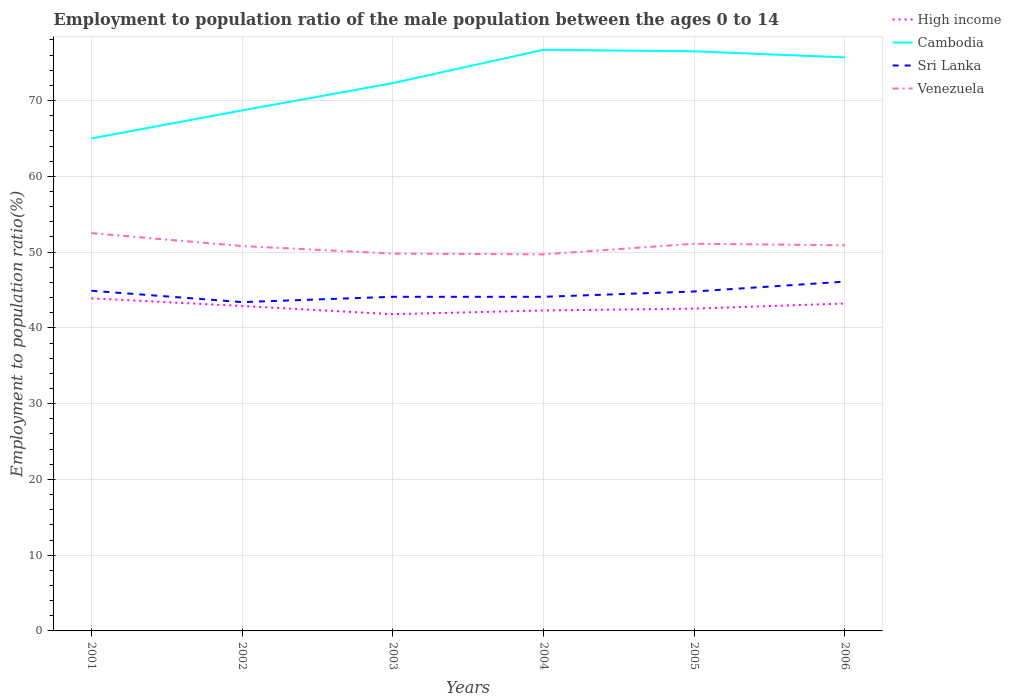How many different coloured lines are there?
Your answer should be very brief. 4. Across all years, what is the maximum employment to population ratio in High income?
Your answer should be compact. 41.8. In which year was the employment to population ratio in Sri Lanka maximum?
Offer a very short reply. 2002. What is the total employment to population ratio in High income in the graph?
Your answer should be compact. 2.09. What is the difference between the highest and the second highest employment to population ratio in High income?
Offer a very short reply. 2.09. Is the employment to population ratio in Cambodia strictly greater than the employment to population ratio in Sri Lanka over the years?
Your answer should be compact. No. How many lines are there?
Make the answer very short. 4. How many years are there in the graph?
Provide a short and direct response. 6. Are the values on the major ticks of Y-axis written in scientific E-notation?
Ensure brevity in your answer.  No. Does the graph contain any zero values?
Your response must be concise. No. Where does the legend appear in the graph?
Offer a terse response. Top right. How are the legend labels stacked?
Your answer should be very brief. Vertical. What is the title of the graph?
Offer a terse response. Employment to population ratio of the male population between the ages 0 to 14. What is the label or title of the Y-axis?
Your answer should be compact. Employment to population ratio(%). What is the Employment to population ratio(%) in High income in 2001?
Your answer should be compact. 43.89. What is the Employment to population ratio(%) in Cambodia in 2001?
Give a very brief answer. 65. What is the Employment to population ratio(%) in Sri Lanka in 2001?
Offer a terse response. 44.9. What is the Employment to population ratio(%) of Venezuela in 2001?
Provide a short and direct response. 52.5. What is the Employment to population ratio(%) in High income in 2002?
Provide a short and direct response. 42.88. What is the Employment to population ratio(%) in Cambodia in 2002?
Your answer should be compact. 68.7. What is the Employment to population ratio(%) in Sri Lanka in 2002?
Your answer should be compact. 43.4. What is the Employment to population ratio(%) in Venezuela in 2002?
Ensure brevity in your answer.  50.8. What is the Employment to population ratio(%) of High income in 2003?
Ensure brevity in your answer.  41.8. What is the Employment to population ratio(%) in Cambodia in 2003?
Give a very brief answer. 72.3. What is the Employment to population ratio(%) in Sri Lanka in 2003?
Provide a succinct answer. 44.1. What is the Employment to population ratio(%) of Venezuela in 2003?
Your answer should be very brief. 49.8. What is the Employment to population ratio(%) in High income in 2004?
Provide a short and direct response. 42.3. What is the Employment to population ratio(%) of Cambodia in 2004?
Your answer should be very brief. 76.7. What is the Employment to population ratio(%) in Sri Lanka in 2004?
Offer a terse response. 44.1. What is the Employment to population ratio(%) of Venezuela in 2004?
Ensure brevity in your answer.  49.7. What is the Employment to population ratio(%) of High income in 2005?
Offer a very short reply. 42.54. What is the Employment to population ratio(%) of Cambodia in 2005?
Make the answer very short. 76.5. What is the Employment to population ratio(%) in Sri Lanka in 2005?
Your answer should be compact. 44.8. What is the Employment to population ratio(%) of Venezuela in 2005?
Offer a terse response. 51.1. What is the Employment to population ratio(%) in High income in 2006?
Give a very brief answer. 43.22. What is the Employment to population ratio(%) in Cambodia in 2006?
Offer a very short reply. 75.7. What is the Employment to population ratio(%) in Sri Lanka in 2006?
Keep it short and to the point. 46.1. What is the Employment to population ratio(%) of Venezuela in 2006?
Your answer should be compact. 50.9. Across all years, what is the maximum Employment to population ratio(%) in High income?
Provide a short and direct response. 43.89. Across all years, what is the maximum Employment to population ratio(%) of Cambodia?
Make the answer very short. 76.7. Across all years, what is the maximum Employment to population ratio(%) of Sri Lanka?
Offer a very short reply. 46.1. Across all years, what is the maximum Employment to population ratio(%) of Venezuela?
Your response must be concise. 52.5. Across all years, what is the minimum Employment to population ratio(%) in High income?
Ensure brevity in your answer.  41.8. Across all years, what is the minimum Employment to population ratio(%) of Cambodia?
Keep it short and to the point. 65. Across all years, what is the minimum Employment to population ratio(%) of Sri Lanka?
Provide a succinct answer. 43.4. Across all years, what is the minimum Employment to population ratio(%) in Venezuela?
Your answer should be compact. 49.7. What is the total Employment to population ratio(%) in High income in the graph?
Give a very brief answer. 256.63. What is the total Employment to population ratio(%) in Cambodia in the graph?
Your response must be concise. 434.9. What is the total Employment to population ratio(%) in Sri Lanka in the graph?
Provide a succinct answer. 267.4. What is the total Employment to population ratio(%) of Venezuela in the graph?
Provide a succinct answer. 304.8. What is the difference between the Employment to population ratio(%) in High income in 2001 and that in 2002?
Provide a succinct answer. 1.01. What is the difference between the Employment to population ratio(%) in Cambodia in 2001 and that in 2002?
Give a very brief answer. -3.7. What is the difference between the Employment to population ratio(%) of Sri Lanka in 2001 and that in 2002?
Keep it short and to the point. 1.5. What is the difference between the Employment to population ratio(%) in Venezuela in 2001 and that in 2002?
Give a very brief answer. 1.7. What is the difference between the Employment to population ratio(%) in High income in 2001 and that in 2003?
Give a very brief answer. 2.09. What is the difference between the Employment to population ratio(%) of Cambodia in 2001 and that in 2003?
Make the answer very short. -7.3. What is the difference between the Employment to population ratio(%) in Venezuela in 2001 and that in 2003?
Offer a terse response. 2.7. What is the difference between the Employment to population ratio(%) in High income in 2001 and that in 2004?
Your answer should be compact. 1.6. What is the difference between the Employment to population ratio(%) in Cambodia in 2001 and that in 2004?
Offer a very short reply. -11.7. What is the difference between the Employment to population ratio(%) of High income in 2001 and that in 2005?
Offer a very short reply. 1.35. What is the difference between the Employment to population ratio(%) in Cambodia in 2001 and that in 2005?
Offer a terse response. -11.5. What is the difference between the Employment to population ratio(%) of Sri Lanka in 2001 and that in 2005?
Give a very brief answer. 0.1. What is the difference between the Employment to population ratio(%) in Venezuela in 2001 and that in 2005?
Your answer should be very brief. 1.4. What is the difference between the Employment to population ratio(%) in High income in 2001 and that in 2006?
Ensure brevity in your answer.  0.68. What is the difference between the Employment to population ratio(%) of Cambodia in 2001 and that in 2006?
Offer a very short reply. -10.7. What is the difference between the Employment to population ratio(%) in High income in 2002 and that in 2003?
Your answer should be very brief. 1.08. What is the difference between the Employment to population ratio(%) of Sri Lanka in 2002 and that in 2003?
Make the answer very short. -0.7. What is the difference between the Employment to population ratio(%) in Venezuela in 2002 and that in 2003?
Your answer should be compact. 1. What is the difference between the Employment to population ratio(%) of High income in 2002 and that in 2004?
Ensure brevity in your answer.  0.58. What is the difference between the Employment to population ratio(%) in Sri Lanka in 2002 and that in 2004?
Make the answer very short. -0.7. What is the difference between the Employment to population ratio(%) of High income in 2002 and that in 2005?
Provide a short and direct response. 0.34. What is the difference between the Employment to population ratio(%) of Cambodia in 2002 and that in 2005?
Offer a very short reply. -7.8. What is the difference between the Employment to population ratio(%) in High income in 2002 and that in 2006?
Your answer should be very brief. -0.33. What is the difference between the Employment to population ratio(%) of High income in 2003 and that in 2004?
Offer a terse response. -0.49. What is the difference between the Employment to population ratio(%) of Cambodia in 2003 and that in 2004?
Make the answer very short. -4.4. What is the difference between the Employment to population ratio(%) in Sri Lanka in 2003 and that in 2004?
Provide a succinct answer. 0. What is the difference between the Employment to population ratio(%) in High income in 2003 and that in 2005?
Give a very brief answer. -0.74. What is the difference between the Employment to population ratio(%) in Cambodia in 2003 and that in 2005?
Make the answer very short. -4.2. What is the difference between the Employment to population ratio(%) of High income in 2003 and that in 2006?
Ensure brevity in your answer.  -1.41. What is the difference between the Employment to population ratio(%) of Sri Lanka in 2003 and that in 2006?
Offer a terse response. -2. What is the difference between the Employment to population ratio(%) of Venezuela in 2003 and that in 2006?
Provide a succinct answer. -1.1. What is the difference between the Employment to population ratio(%) of High income in 2004 and that in 2005?
Provide a short and direct response. -0.24. What is the difference between the Employment to population ratio(%) of High income in 2004 and that in 2006?
Keep it short and to the point. -0.92. What is the difference between the Employment to population ratio(%) in Cambodia in 2004 and that in 2006?
Your answer should be compact. 1. What is the difference between the Employment to population ratio(%) of Sri Lanka in 2004 and that in 2006?
Your answer should be compact. -2. What is the difference between the Employment to population ratio(%) in Venezuela in 2004 and that in 2006?
Offer a very short reply. -1.2. What is the difference between the Employment to population ratio(%) in High income in 2005 and that in 2006?
Give a very brief answer. -0.68. What is the difference between the Employment to population ratio(%) of Cambodia in 2005 and that in 2006?
Provide a short and direct response. 0.8. What is the difference between the Employment to population ratio(%) of Venezuela in 2005 and that in 2006?
Your response must be concise. 0.2. What is the difference between the Employment to population ratio(%) in High income in 2001 and the Employment to population ratio(%) in Cambodia in 2002?
Offer a terse response. -24.81. What is the difference between the Employment to population ratio(%) of High income in 2001 and the Employment to population ratio(%) of Sri Lanka in 2002?
Your answer should be very brief. 0.49. What is the difference between the Employment to population ratio(%) in High income in 2001 and the Employment to population ratio(%) in Venezuela in 2002?
Ensure brevity in your answer.  -6.91. What is the difference between the Employment to population ratio(%) in Cambodia in 2001 and the Employment to population ratio(%) in Sri Lanka in 2002?
Ensure brevity in your answer.  21.6. What is the difference between the Employment to population ratio(%) of Cambodia in 2001 and the Employment to population ratio(%) of Venezuela in 2002?
Keep it short and to the point. 14.2. What is the difference between the Employment to population ratio(%) of Sri Lanka in 2001 and the Employment to population ratio(%) of Venezuela in 2002?
Your response must be concise. -5.9. What is the difference between the Employment to population ratio(%) of High income in 2001 and the Employment to population ratio(%) of Cambodia in 2003?
Give a very brief answer. -28.41. What is the difference between the Employment to population ratio(%) in High income in 2001 and the Employment to population ratio(%) in Sri Lanka in 2003?
Keep it short and to the point. -0.21. What is the difference between the Employment to population ratio(%) in High income in 2001 and the Employment to population ratio(%) in Venezuela in 2003?
Ensure brevity in your answer.  -5.91. What is the difference between the Employment to population ratio(%) in Cambodia in 2001 and the Employment to population ratio(%) in Sri Lanka in 2003?
Your answer should be compact. 20.9. What is the difference between the Employment to population ratio(%) in Sri Lanka in 2001 and the Employment to population ratio(%) in Venezuela in 2003?
Give a very brief answer. -4.9. What is the difference between the Employment to population ratio(%) of High income in 2001 and the Employment to population ratio(%) of Cambodia in 2004?
Offer a very short reply. -32.81. What is the difference between the Employment to population ratio(%) in High income in 2001 and the Employment to population ratio(%) in Sri Lanka in 2004?
Provide a succinct answer. -0.21. What is the difference between the Employment to population ratio(%) of High income in 2001 and the Employment to population ratio(%) of Venezuela in 2004?
Offer a terse response. -5.81. What is the difference between the Employment to population ratio(%) of Cambodia in 2001 and the Employment to population ratio(%) of Sri Lanka in 2004?
Offer a very short reply. 20.9. What is the difference between the Employment to population ratio(%) of Sri Lanka in 2001 and the Employment to population ratio(%) of Venezuela in 2004?
Offer a terse response. -4.8. What is the difference between the Employment to population ratio(%) in High income in 2001 and the Employment to population ratio(%) in Cambodia in 2005?
Your answer should be compact. -32.61. What is the difference between the Employment to population ratio(%) in High income in 2001 and the Employment to population ratio(%) in Sri Lanka in 2005?
Your answer should be compact. -0.91. What is the difference between the Employment to population ratio(%) of High income in 2001 and the Employment to population ratio(%) of Venezuela in 2005?
Give a very brief answer. -7.21. What is the difference between the Employment to population ratio(%) of Cambodia in 2001 and the Employment to population ratio(%) of Sri Lanka in 2005?
Your answer should be very brief. 20.2. What is the difference between the Employment to population ratio(%) of Cambodia in 2001 and the Employment to population ratio(%) of Venezuela in 2005?
Your response must be concise. 13.9. What is the difference between the Employment to population ratio(%) of High income in 2001 and the Employment to population ratio(%) of Cambodia in 2006?
Your answer should be compact. -31.81. What is the difference between the Employment to population ratio(%) in High income in 2001 and the Employment to population ratio(%) in Sri Lanka in 2006?
Provide a succinct answer. -2.21. What is the difference between the Employment to population ratio(%) in High income in 2001 and the Employment to population ratio(%) in Venezuela in 2006?
Ensure brevity in your answer.  -7.01. What is the difference between the Employment to population ratio(%) in Cambodia in 2001 and the Employment to population ratio(%) in Sri Lanka in 2006?
Make the answer very short. 18.9. What is the difference between the Employment to population ratio(%) of High income in 2002 and the Employment to population ratio(%) of Cambodia in 2003?
Your answer should be compact. -29.42. What is the difference between the Employment to population ratio(%) of High income in 2002 and the Employment to population ratio(%) of Sri Lanka in 2003?
Your response must be concise. -1.22. What is the difference between the Employment to population ratio(%) in High income in 2002 and the Employment to population ratio(%) in Venezuela in 2003?
Offer a very short reply. -6.92. What is the difference between the Employment to population ratio(%) of Cambodia in 2002 and the Employment to population ratio(%) of Sri Lanka in 2003?
Your answer should be very brief. 24.6. What is the difference between the Employment to population ratio(%) of Cambodia in 2002 and the Employment to population ratio(%) of Venezuela in 2003?
Keep it short and to the point. 18.9. What is the difference between the Employment to population ratio(%) of High income in 2002 and the Employment to population ratio(%) of Cambodia in 2004?
Make the answer very short. -33.82. What is the difference between the Employment to population ratio(%) in High income in 2002 and the Employment to population ratio(%) in Sri Lanka in 2004?
Make the answer very short. -1.22. What is the difference between the Employment to population ratio(%) in High income in 2002 and the Employment to population ratio(%) in Venezuela in 2004?
Keep it short and to the point. -6.82. What is the difference between the Employment to population ratio(%) of Cambodia in 2002 and the Employment to population ratio(%) of Sri Lanka in 2004?
Make the answer very short. 24.6. What is the difference between the Employment to population ratio(%) in High income in 2002 and the Employment to population ratio(%) in Cambodia in 2005?
Your answer should be compact. -33.62. What is the difference between the Employment to population ratio(%) in High income in 2002 and the Employment to population ratio(%) in Sri Lanka in 2005?
Your response must be concise. -1.92. What is the difference between the Employment to population ratio(%) of High income in 2002 and the Employment to population ratio(%) of Venezuela in 2005?
Offer a terse response. -8.22. What is the difference between the Employment to population ratio(%) in Cambodia in 2002 and the Employment to population ratio(%) in Sri Lanka in 2005?
Your answer should be compact. 23.9. What is the difference between the Employment to population ratio(%) in Sri Lanka in 2002 and the Employment to population ratio(%) in Venezuela in 2005?
Offer a terse response. -7.7. What is the difference between the Employment to population ratio(%) of High income in 2002 and the Employment to population ratio(%) of Cambodia in 2006?
Your answer should be compact. -32.82. What is the difference between the Employment to population ratio(%) of High income in 2002 and the Employment to population ratio(%) of Sri Lanka in 2006?
Your answer should be compact. -3.22. What is the difference between the Employment to population ratio(%) in High income in 2002 and the Employment to population ratio(%) in Venezuela in 2006?
Offer a very short reply. -8.02. What is the difference between the Employment to population ratio(%) of Cambodia in 2002 and the Employment to population ratio(%) of Sri Lanka in 2006?
Make the answer very short. 22.6. What is the difference between the Employment to population ratio(%) of Cambodia in 2002 and the Employment to population ratio(%) of Venezuela in 2006?
Your answer should be compact. 17.8. What is the difference between the Employment to population ratio(%) in High income in 2003 and the Employment to population ratio(%) in Cambodia in 2004?
Make the answer very short. -34.9. What is the difference between the Employment to population ratio(%) in High income in 2003 and the Employment to population ratio(%) in Sri Lanka in 2004?
Your answer should be compact. -2.3. What is the difference between the Employment to population ratio(%) of High income in 2003 and the Employment to population ratio(%) of Venezuela in 2004?
Your answer should be compact. -7.9. What is the difference between the Employment to population ratio(%) of Cambodia in 2003 and the Employment to population ratio(%) of Sri Lanka in 2004?
Provide a short and direct response. 28.2. What is the difference between the Employment to population ratio(%) of Cambodia in 2003 and the Employment to population ratio(%) of Venezuela in 2004?
Make the answer very short. 22.6. What is the difference between the Employment to population ratio(%) in Sri Lanka in 2003 and the Employment to population ratio(%) in Venezuela in 2004?
Your response must be concise. -5.6. What is the difference between the Employment to population ratio(%) of High income in 2003 and the Employment to population ratio(%) of Cambodia in 2005?
Give a very brief answer. -34.7. What is the difference between the Employment to population ratio(%) of High income in 2003 and the Employment to population ratio(%) of Sri Lanka in 2005?
Give a very brief answer. -3. What is the difference between the Employment to population ratio(%) in High income in 2003 and the Employment to population ratio(%) in Venezuela in 2005?
Offer a terse response. -9.3. What is the difference between the Employment to population ratio(%) in Cambodia in 2003 and the Employment to population ratio(%) in Sri Lanka in 2005?
Ensure brevity in your answer.  27.5. What is the difference between the Employment to population ratio(%) of Cambodia in 2003 and the Employment to population ratio(%) of Venezuela in 2005?
Offer a very short reply. 21.2. What is the difference between the Employment to population ratio(%) of High income in 2003 and the Employment to population ratio(%) of Cambodia in 2006?
Give a very brief answer. -33.9. What is the difference between the Employment to population ratio(%) of High income in 2003 and the Employment to population ratio(%) of Sri Lanka in 2006?
Make the answer very short. -4.3. What is the difference between the Employment to population ratio(%) of High income in 2003 and the Employment to population ratio(%) of Venezuela in 2006?
Keep it short and to the point. -9.1. What is the difference between the Employment to population ratio(%) in Cambodia in 2003 and the Employment to population ratio(%) in Sri Lanka in 2006?
Provide a succinct answer. 26.2. What is the difference between the Employment to population ratio(%) in Cambodia in 2003 and the Employment to population ratio(%) in Venezuela in 2006?
Your answer should be very brief. 21.4. What is the difference between the Employment to population ratio(%) of Sri Lanka in 2003 and the Employment to population ratio(%) of Venezuela in 2006?
Offer a terse response. -6.8. What is the difference between the Employment to population ratio(%) of High income in 2004 and the Employment to population ratio(%) of Cambodia in 2005?
Keep it short and to the point. -34.2. What is the difference between the Employment to population ratio(%) in High income in 2004 and the Employment to population ratio(%) in Sri Lanka in 2005?
Your answer should be very brief. -2.5. What is the difference between the Employment to population ratio(%) in High income in 2004 and the Employment to population ratio(%) in Venezuela in 2005?
Offer a very short reply. -8.8. What is the difference between the Employment to population ratio(%) of Cambodia in 2004 and the Employment to population ratio(%) of Sri Lanka in 2005?
Keep it short and to the point. 31.9. What is the difference between the Employment to population ratio(%) in Cambodia in 2004 and the Employment to population ratio(%) in Venezuela in 2005?
Provide a succinct answer. 25.6. What is the difference between the Employment to population ratio(%) of High income in 2004 and the Employment to population ratio(%) of Cambodia in 2006?
Offer a terse response. -33.4. What is the difference between the Employment to population ratio(%) in High income in 2004 and the Employment to population ratio(%) in Sri Lanka in 2006?
Give a very brief answer. -3.8. What is the difference between the Employment to population ratio(%) of High income in 2004 and the Employment to population ratio(%) of Venezuela in 2006?
Provide a succinct answer. -8.6. What is the difference between the Employment to population ratio(%) in Cambodia in 2004 and the Employment to population ratio(%) in Sri Lanka in 2006?
Provide a succinct answer. 30.6. What is the difference between the Employment to population ratio(%) in Cambodia in 2004 and the Employment to population ratio(%) in Venezuela in 2006?
Ensure brevity in your answer.  25.8. What is the difference between the Employment to population ratio(%) in Sri Lanka in 2004 and the Employment to population ratio(%) in Venezuela in 2006?
Offer a very short reply. -6.8. What is the difference between the Employment to population ratio(%) in High income in 2005 and the Employment to population ratio(%) in Cambodia in 2006?
Offer a terse response. -33.16. What is the difference between the Employment to population ratio(%) in High income in 2005 and the Employment to population ratio(%) in Sri Lanka in 2006?
Make the answer very short. -3.56. What is the difference between the Employment to population ratio(%) of High income in 2005 and the Employment to population ratio(%) of Venezuela in 2006?
Your answer should be compact. -8.36. What is the difference between the Employment to population ratio(%) of Cambodia in 2005 and the Employment to population ratio(%) of Sri Lanka in 2006?
Your response must be concise. 30.4. What is the difference between the Employment to population ratio(%) in Cambodia in 2005 and the Employment to population ratio(%) in Venezuela in 2006?
Your answer should be compact. 25.6. What is the difference between the Employment to population ratio(%) of Sri Lanka in 2005 and the Employment to population ratio(%) of Venezuela in 2006?
Make the answer very short. -6.1. What is the average Employment to population ratio(%) in High income per year?
Ensure brevity in your answer.  42.77. What is the average Employment to population ratio(%) in Cambodia per year?
Make the answer very short. 72.48. What is the average Employment to population ratio(%) of Sri Lanka per year?
Ensure brevity in your answer.  44.57. What is the average Employment to population ratio(%) of Venezuela per year?
Ensure brevity in your answer.  50.8. In the year 2001, what is the difference between the Employment to population ratio(%) of High income and Employment to population ratio(%) of Cambodia?
Offer a very short reply. -21.11. In the year 2001, what is the difference between the Employment to population ratio(%) in High income and Employment to population ratio(%) in Sri Lanka?
Provide a succinct answer. -1.01. In the year 2001, what is the difference between the Employment to population ratio(%) in High income and Employment to population ratio(%) in Venezuela?
Offer a very short reply. -8.61. In the year 2001, what is the difference between the Employment to population ratio(%) of Cambodia and Employment to population ratio(%) of Sri Lanka?
Keep it short and to the point. 20.1. In the year 2002, what is the difference between the Employment to population ratio(%) in High income and Employment to population ratio(%) in Cambodia?
Offer a very short reply. -25.82. In the year 2002, what is the difference between the Employment to population ratio(%) in High income and Employment to population ratio(%) in Sri Lanka?
Your response must be concise. -0.52. In the year 2002, what is the difference between the Employment to population ratio(%) of High income and Employment to population ratio(%) of Venezuela?
Your response must be concise. -7.92. In the year 2002, what is the difference between the Employment to population ratio(%) in Cambodia and Employment to population ratio(%) in Sri Lanka?
Make the answer very short. 25.3. In the year 2002, what is the difference between the Employment to population ratio(%) of Cambodia and Employment to population ratio(%) of Venezuela?
Offer a very short reply. 17.9. In the year 2003, what is the difference between the Employment to population ratio(%) in High income and Employment to population ratio(%) in Cambodia?
Your answer should be compact. -30.5. In the year 2003, what is the difference between the Employment to population ratio(%) in High income and Employment to population ratio(%) in Sri Lanka?
Your answer should be compact. -2.3. In the year 2003, what is the difference between the Employment to population ratio(%) of High income and Employment to population ratio(%) of Venezuela?
Provide a short and direct response. -8. In the year 2003, what is the difference between the Employment to population ratio(%) in Cambodia and Employment to population ratio(%) in Sri Lanka?
Your answer should be compact. 28.2. In the year 2003, what is the difference between the Employment to population ratio(%) of Cambodia and Employment to population ratio(%) of Venezuela?
Offer a terse response. 22.5. In the year 2003, what is the difference between the Employment to population ratio(%) in Sri Lanka and Employment to population ratio(%) in Venezuela?
Your answer should be compact. -5.7. In the year 2004, what is the difference between the Employment to population ratio(%) in High income and Employment to population ratio(%) in Cambodia?
Provide a short and direct response. -34.4. In the year 2004, what is the difference between the Employment to population ratio(%) of High income and Employment to population ratio(%) of Sri Lanka?
Your answer should be very brief. -1.8. In the year 2004, what is the difference between the Employment to population ratio(%) in High income and Employment to population ratio(%) in Venezuela?
Your answer should be compact. -7.4. In the year 2004, what is the difference between the Employment to population ratio(%) in Cambodia and Employment to population ratio(%) in Sri Lanka?
Provide a succinct answer. 32.6. In the year 2004, what is the difference between the Employment to population ratio(%) in Sri Lanka and Employment to population ratio(%) in Venezuela?
Your response must be concise. -5.6. In the year 2005, what is the difference between the Employment to population ratio(%) in High income and Employment to population ratio(%) in Cambodia?
Your answer should be compact. -33.96. In the year 2005, what is the difference between the Employment to population ratio(%) of High income and Employment to population ratio(%) of Sri Lanka?
Keep it short and to the point. -2.26. In the year 2005, what is the difference between the Employment to population ratio(%) of High income and Employment to population ratio(%) of Venezuela?
Ensure brevity in your answer.  -8.56. In the year 2005, what is the difference between the Employment to population ratio(%) in Cambodia and Employment to population ratio(%) in Sri Lanka?
Ensure brevity in your answer.  31.7. In the year 2005, what is the difference between the Employment to population ratio(%) of Cambodia and Employment to population ratio(%) of Venezuela?
Your answer should be very brief. 25.4. In the year 2006, what is the difference between the Employment to population ratio(%) in High income and Employment to population ratio(%) in Cambodia?
Provide a short and direct response. -32.48. In the year 2006, what is the difference between the Employment to population ratio(%) in High income and Employment to population ratio(%) in Sri Lanka?
Ensure brevity in your answer.  -2.88. In the year 2006, what is the difference between the Employment to population ratio(%) of High income and Employment to population ratio(%) of Venezuela?
Your answer should be compact. -7.68. In the year 2006, what is the difference between the Employment to population ratio(%) in Cambodia and Employment to population ratio(%) in Sri Lanka?
Offer a terse response. 29.6. In the year 2006, what is the difference between the Employment to population ratio(%) of Cambodia and Employment to population ratio(%) of Venezuela?
Make the answer very short. 24.8. What is the ratio of the Employment to population ratio(%) in High income in 2001 to that in 2002?
Make the answer very short. 1.02. What is the ratio of the Employment to population ratio(%) of Cambodia in 2001 to that in 2002?
Ensure brevity in your answer.  0.95. What is the ratio of the Employment to population ratio(%) in Sri Lanka in 2001 to that in 2002?
Make the answer very short. 1.03. What is the ratio of the Employment to population ratio(%) in Venezuela in 2001 to that in 2002?
Offer a very short reply. 1.03. What is the ratio of the Employment to population ratio(%) of High income in 2001 to that in 2003?
Offer a very short reply. 1.05. What is the ratio of the Employment to population ratio(%) in Cambodia in 2001 to that in 2003?
Give a very brief answer. 0.9. What is the ratio of the Employment to population ratio(%) of Sri Lanka in 2001 to that in 2003?
Offer a very short reply. 1.02. What is the ratio of the Employment to population ratio(%) in Venezuela in 2001 to that in 2003?
Ensure brevity in your answer.  1.05. What is the ratio of the Employment to population ratio(%) in High income in 2001 to that in 2004?
Make the answer very short. 1.04. What is the ratio of the Employment to population ratio(%) in Cambodia in 2001 to that in 2004?
Provide a succinct answer. 0.85. What is the ratio of the Employment to population ratio(%) in Sri Lanka in 2001 to that in 2004?
Offer a terse response. 1.02. What is the ratio of the Employment to population ratio(%) of Venezuela in 2001 to that in 2004?
Your response must be concise. 1.06. What is the ratio of the Employment to population ratio(%) of High income in 2001 to that in 2005?
Your answer should be compact. 1.03. What is the ratio of the Employment to population ratio(%) in Cambodia in 2001 to that in 2005?
Your answer should be compact. 0.85. What is the ratio of the Employment to population ratio(%) in Venezuela in 2001 to that in 2005?
Give a very brief answer. 1.03. What is the ratio of the Employment to population ratio(%) of High income in 2001 to that in 2006?
Your response must be concise. 1.02. What is the ratio of the Employment to population ratio(%) of Cambodia in 2001 to that in 2006?
Offer a very short reply. 0.86. What is the ratio of the Employment to population ratio(%) in Sri Lanka in 2001 to that in 2006?
Keep it short and to the point. 0.97. What is the ratio of the Employment to population ratio(%) of Venezuela in 2001 to that in 2006?
Provide a short and direct response. 1.03. What is the ratio of the Employment to population ratio(%) in High income in 2002 to that in 2003?
Your answer should be compact. 1.03. What is the ratio of the Employment to population ratio(%) in Cambodia in 2002 to that in 2003?
Keep it short and to the point. 0.95. What is the ratio of the Employment to population ratio(%) in Sri Lanka in 2002 to that in 2003?
Your response must be concise. 0.98. What is the ratio of the Employment to population ratio(%) in Venezuela in 2002 to that in 2003?
Your answer should be very brief. 1.02. What is the ratio of the Employment to population ratio(%) of High income in 2002 to that in 2004?
Offer a terse response. 1.01. What is the ratio of the Employment to population ratio(%) of Cambodia in 2002 to that in 2004?
Offer a terse response. 0.9. What is the ratio of the Employment to population ratio(%) in Sri Lanka in 2002 to that in 2004?
Your answer should be compact. 0.98. What is the ratio of the Employment to population ratio(%) in Venezuela in 2002 to that in 2004?
Offer a terse response. 1.02. What is the ratio of the Employment to population ratio(%) in High income in 2002 to that in 2005?
Offer a very short reply. 1.01. What is the ratio of the Employment to population ratio(%) of Cambodia in 2002 to that in 2005?
Make the answer very short. 0.9. What is the ratio of the Employment to population ratio(%) of Sri Lanka in 2002 to that in 2005?
Provide a succinct answer. 0.97. What is the ratio of the Employment to population ratio(%) in Cambodia in 2002 to that in 2006?
Provide a succinct answer. 0.91. What is the ratio of the Employment to population ratio(%) in Sri Lanka in 2002 to that in 2006?
Your answer should be very brief. 0.94. What is the ratio of the Employment to population ratio(%) of Venezuela in 2002 to that in 2006?
Keep it short and to the point. 1. What is the ratio of the Employment to population ratio(%) of High income in 2003 to that in 2004?
Provide a short and direct response. 0.99. What is the ratio of the Employment to population ratio(%) of Cambodia in 2003 to that in 2004?
Your response must be concise. 0.94. What is the ratio of the Employment to population ratio(%) of Venezuela in 2003 to that in 2004?
Make the answer very short. 1. What is the ratio of the Employment to population ratio(%) in High income in 2003 to that in 2005?
Give a very brief answer. 0.98. What is the ratio of the Employment to population ratio(%) in Cambodia in 2003 to that in 2005?
Your answer should be compact. 0.95. What is the ratio of the Employment to population ratio(%) of Sri Lanka in 2003 to that in 2005?
Offer a terse response. 0.98. What is the ratio of the Employment to population ratio(%) in Venezuela in 2003 to that in 2005?
Offer a terse response. 0.97. What is the ratio of the Employment to population ratio(%) in High income in 2003 to that in 2006?
Keep it short and to the point. 0.97. What is the ratio of the Employment to population ratio(%) of Cambodia in 2003 to that in 2006?
Your response must be concise. 0.96. What is the ratio of the Employment to population ratio(%) in Sri Lanka in 2003 to that in 2006?
Make the answer very short. 0.96. What is the ratio of the Employment to population ratio(%) of Venezuela in 2003 to that in 2006?
Offer a very short reply. 0.98. What is the ratio of the Employment to population ratio(%) of Cambodia in 2004 to that in 2005?
Keep it short and to the point. 1. What is the ratio of the Employment to population ratio(%) in Sri Lanka in 2004 to that in 2005?
Offer a terse response. 0.98. What is the ratio of the Employment to population ratio(%) of Venezuela in 2004 to that in 2005?
Provide a succinct answer. 0.97. What is the ratio of the Employment to population ratio(%) in High income in 2004 to that in 2006?
Your answer should be very brief. 0.98. What is the ratio of the Employment to population ratio(%) of Cambodia in 2004 to that in 2006?
Give a very brief answer. 1.01. What is the ratio of the Employment to population ratio(%) in Sri Lanka in 2004 to that in 2006?
Give a very brief answer. 0.96. What is the ratio of the Employment to population ratio(%) in Venezuela in 2004 to that in 2006?
Make the answer very short. 0.98. What is the ratio of the Employment to population ratio(%) in High income in 2005 to that in 2006?
Ensure brevity in your answer.  0.98. What is the ratio of the Employment to population ratio(%) in Cambodia in 2005 to that in 2006?
Your response must be concise. 1.01. What is the ratio of the Employment to population ratio(%) in Sri Lanka in 2005 to that in 2006?
Provide a short and direct response. 0.97. What is the ratio of the Employment to population ratio(%) of Venezuela in 2005 to that in 2006?
Give a very brief answer. 1. What is the difference between the highest and the second highest Employment to population ratio(%) in High income?
Provide a short and direct response. 0.68. What is the difference between the highest and the second highest Employment to population ratio(%) of Venezuela?
Your answer should be compact. 1.4. What is the difference between the highest and the lowest Employment to population ratio(%) of High income?
Your answer should be compact. 2.09. What is the difference between the highest and the lowest Employment to population ratio(%) of Cambodia?
Provide a short and direct response. 11.7. 